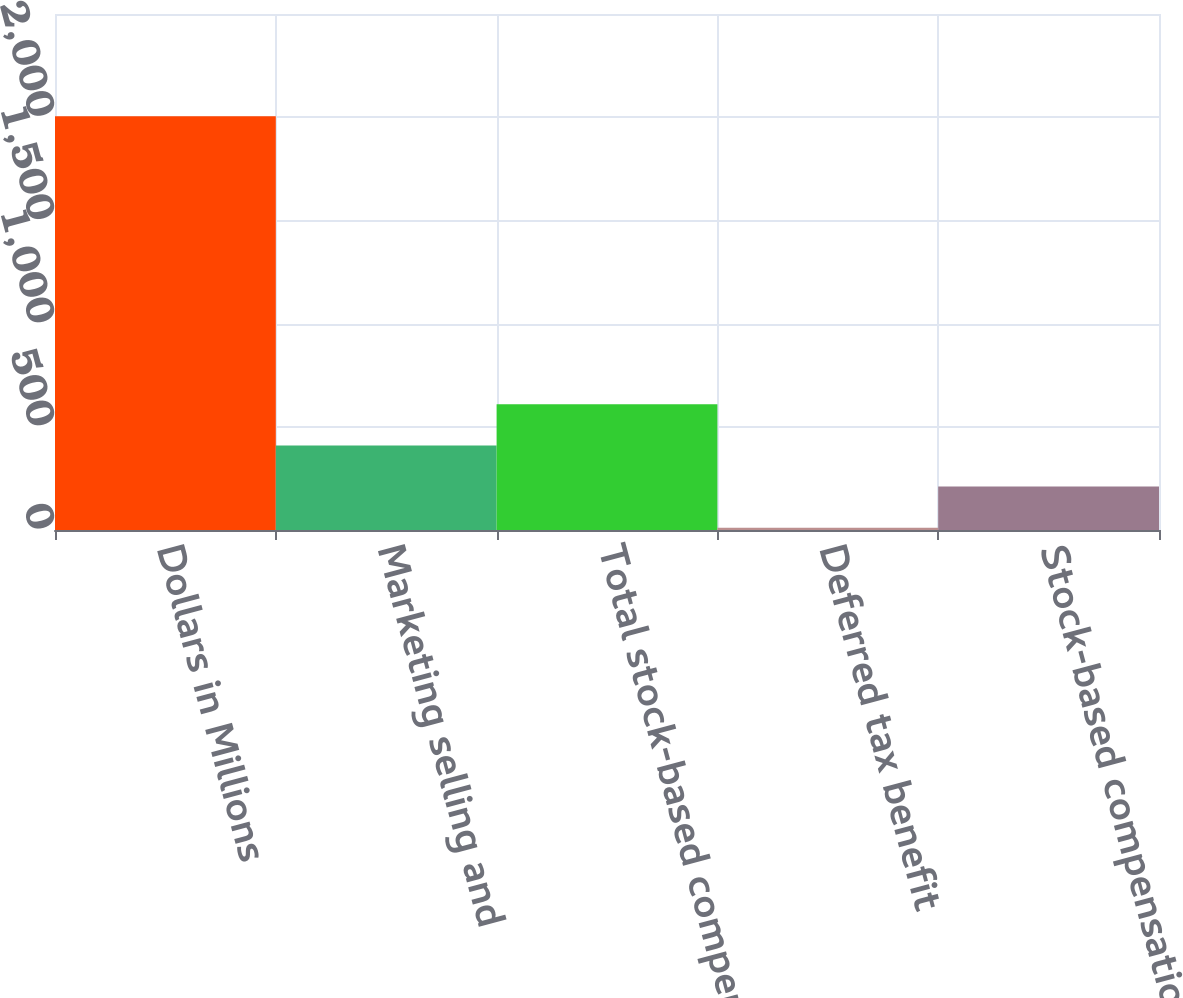Convert chart to OTSL. <chart><loc_0><loc_0><loc_500><loc_500><bar_chart><fcel>Dollars in Millions<fcel>Marketing selling and<fcel>Total stock-based compensation<fcel>Deferred tax benefit<fcel>Stock-based compensation net<nl><fcel>2005<fcel>409.8<fcel>609.2<fcel>11<fcel>210.4<nl></chart> 